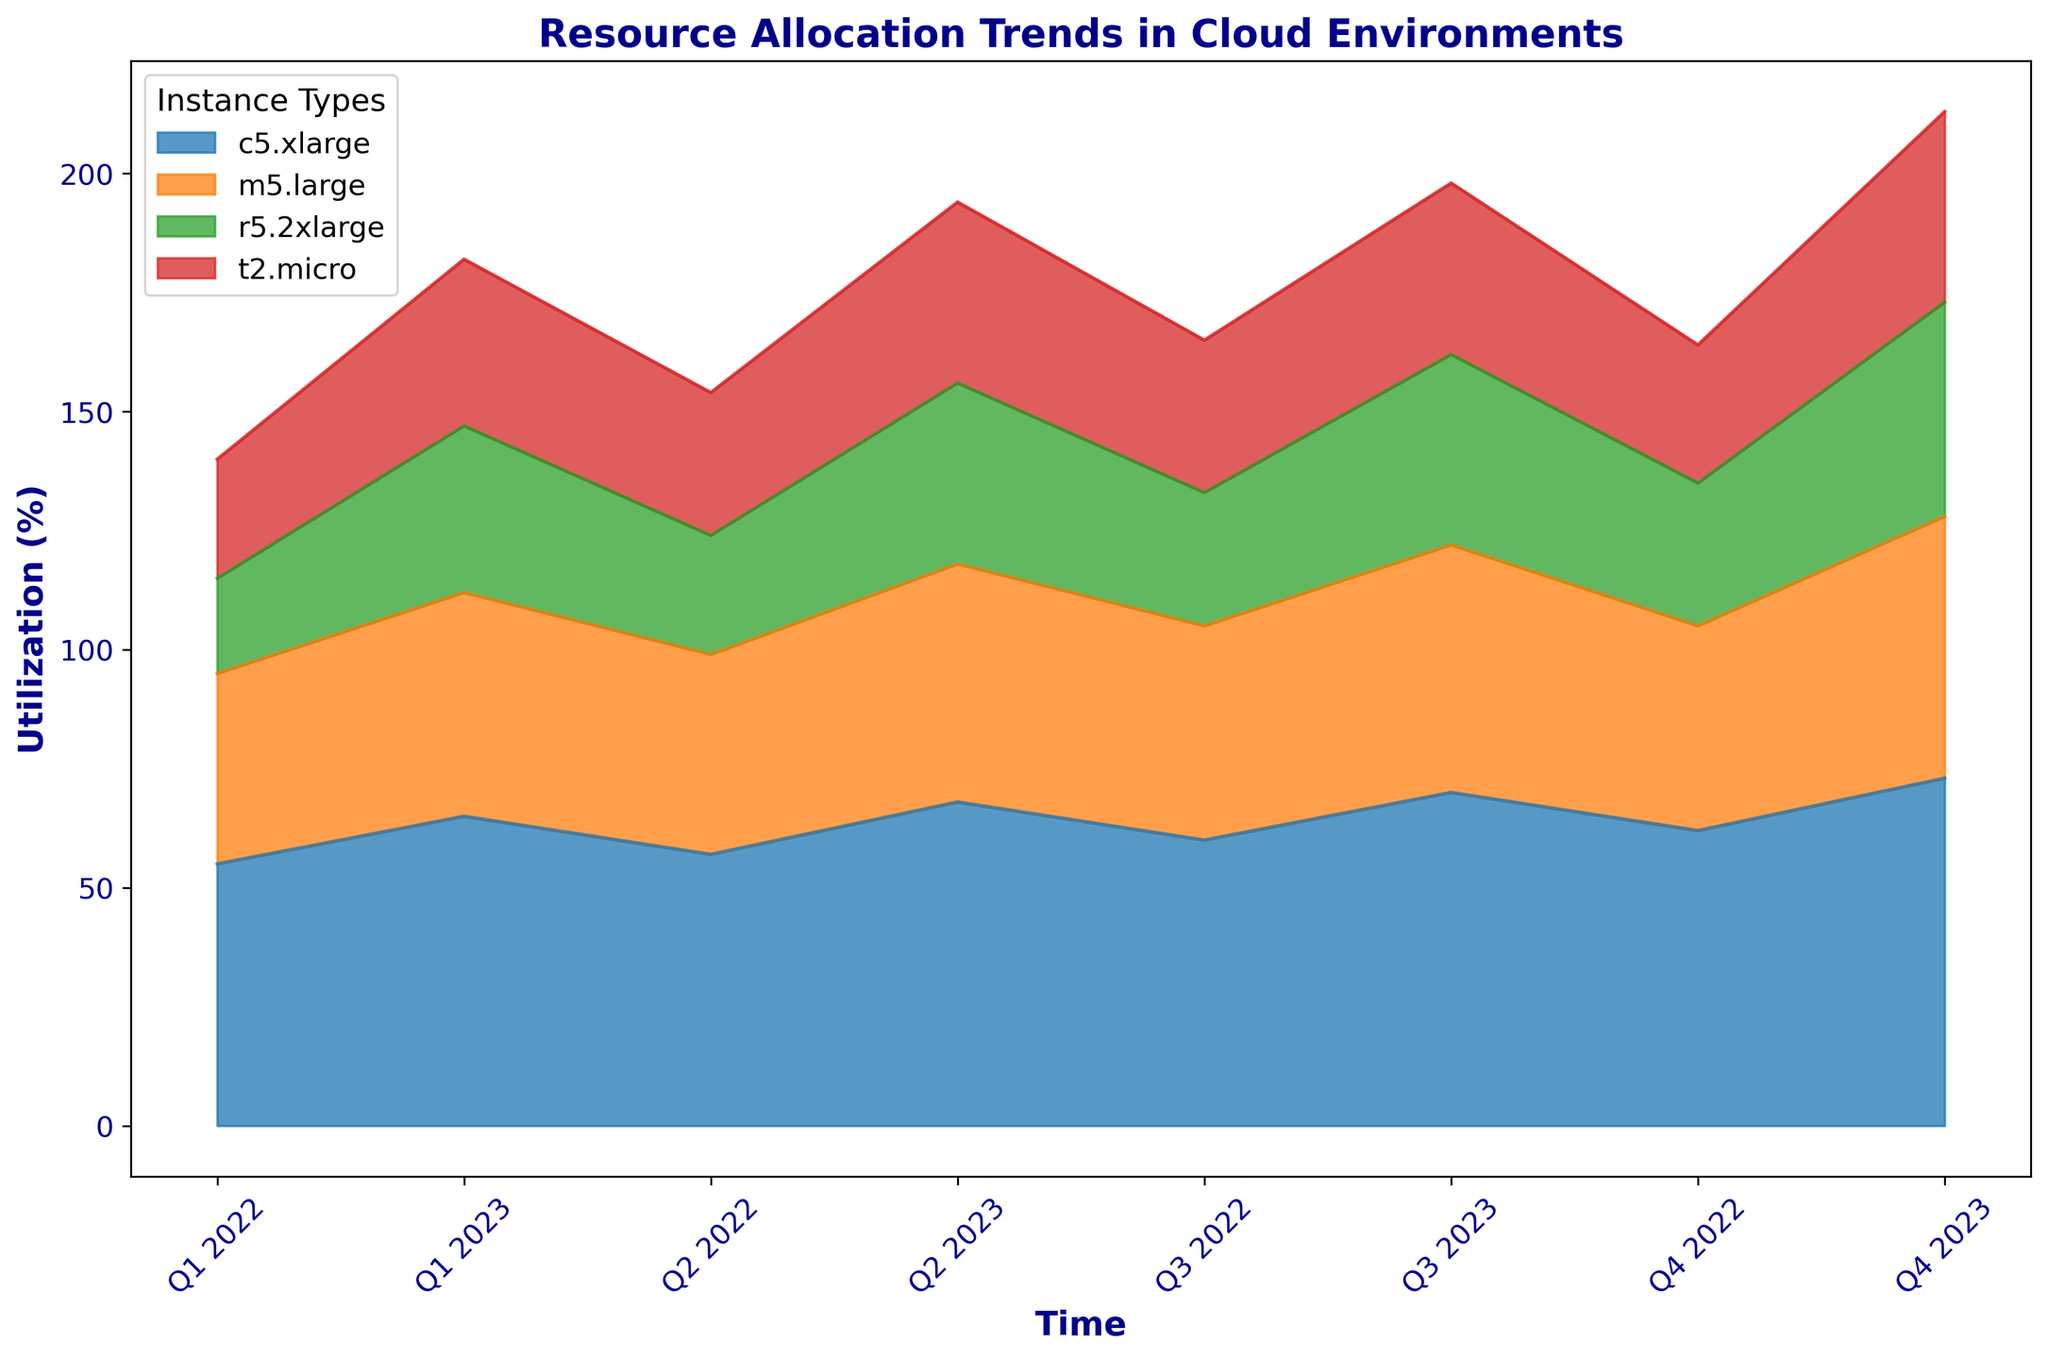What's the total utilization of all instance types combined for Q1 2022? First, locate Q1 2022 on the x-axis. Then, identify the utilization values for each instance type at that time point: t2.micro (25), m5.large (40), c5.xlarge (55), and r5.2xlarge (20). Sum these values: 25 + 40 + 55 + 20 = 140.
Answer: 140 Which instance type shows the highest increase in utilization from Q1 2022 to Q4 2023? Identify the utilization values for each instance type at Q1 2022 and Q4 2023. Calculate the difference for each: t2.micro (40-25=15), m5.large (55-40=15), c5.xlarge (73-55=18), and r5.2xlarge (45-20=25). The instance type with the highest increase is r5.2xlarge (25).
Answer: r5.2xlarge Which quarter has the highest overall utilization for all instance types combined? Sum the utilization values for all instance types for each quarter. The highest overall utilization is likely at the end of the period since the trend shows an increase for all instances. Verify by summing values for Q4 2023: t2.micro (40), m5.large (55), c5.xlarge (73), r5.2xlarge (45). The total is 40 + 55 + 73 + 45 = 213, the highest compared to other quarters.
Answer: Q4 2023 Is the utilization of t2.micro ever higher than that of m5.large? Observe the area charts representing t2.micro and m5.large utilization across all quarters. Compare their values for each quarter. At no point does t2.micro's utilization exceed m5.large's utilization.
Answer: No Between which two consecutive quarters does c5.xlarge show the highest change in utilization? Locate the c5.xlarge values for each quarter and calculate the differences between consecutive quarters: Q2-Q1 (2), Q3-Q2 (3), Q4-Q3 (2), Q1-Q4 (3), Q2-Q1 (3), Q3-Q2 (2), Q4-Q3 (3). The highest change occurs between Q2-Q1 2023.
Answer: Q2-Q1 2023 Which instance type has the least increase in utilization from Q1 2022 to Q2 2023? Calculate the increases for each instance type between Q1 2022 and Q2 2023: t2.micro (13), m5.large (10), c5.xlarge (13), r5.2xlarge (18). The instance type with the least increase is m5.large.
Answer: m5.large How does the utilization trend of m5.large compare to r5.2xlarge over the entire period? Visually analyze the trends by tracking the areas representing m5.large and r5.2xlarge utilization. Both show an increasing trend, but r5.2xlarge begins lower and has a sharper increase towards the end. m5.large has a steadier and relatively moderate increase.
Answer: Both increase; r5.2xlarge sharper What is the average utilization of c5.xlarge throughout the observed period? Note the utilization values for c5.xlarge for each quarter: 55, 57, 60, 62, 65, 68, 70, 73. Calculate the average: (55 + 57 + 60 + 62 + 65 + 68 + 70 + 73) / 8 = 63.75.
Answer: 63.75 Which quarter shows the highest utilization for t2.micro? Identify the utilization values for t2.micro across all quarters and find the maximum value. The highest utilization for t2.micro is 40 in Q4 2023.
Answer: Q4 2023 During which quarter is the combined utilization of m5.large and c5.xlarge the highest? Calculate the combined utilization of m5.large and c5.xlarge for each quarter and identify the maximum. The combined utilization for Q4 2023: 55 (m5.large) + 73 (c5.xlarge) = 128, the highest compared to other quarters.
Answer: Q4 2023 